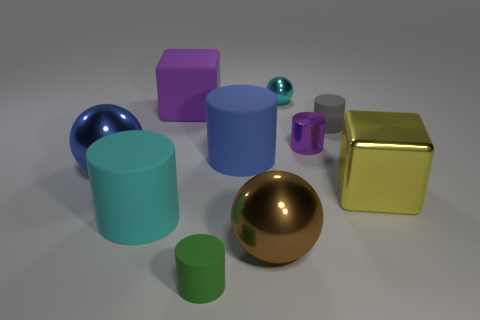Subtract 1 balls. How many balls are left? 2 Subtract all blue cylinders. How many cylinders are left? 4 Subtract all green rubber cylinders. How many cylinders are left? 4 Subtract all cyan cylinders. Subtract all brown blocks. How many cylinders are left? 4 Subtract all spheres. How many objects are left? 7 Add 3 large matte balls. How many large matte balls exist? 3 Subtract 0 red spheres. How many objects are left? 10 Subtract all big blue rubber things. Subtract all big yellow blocks. How many objects are left? 8 Add 3 large purple rubber cubes. How many large purple rubber cubes are left? 4 